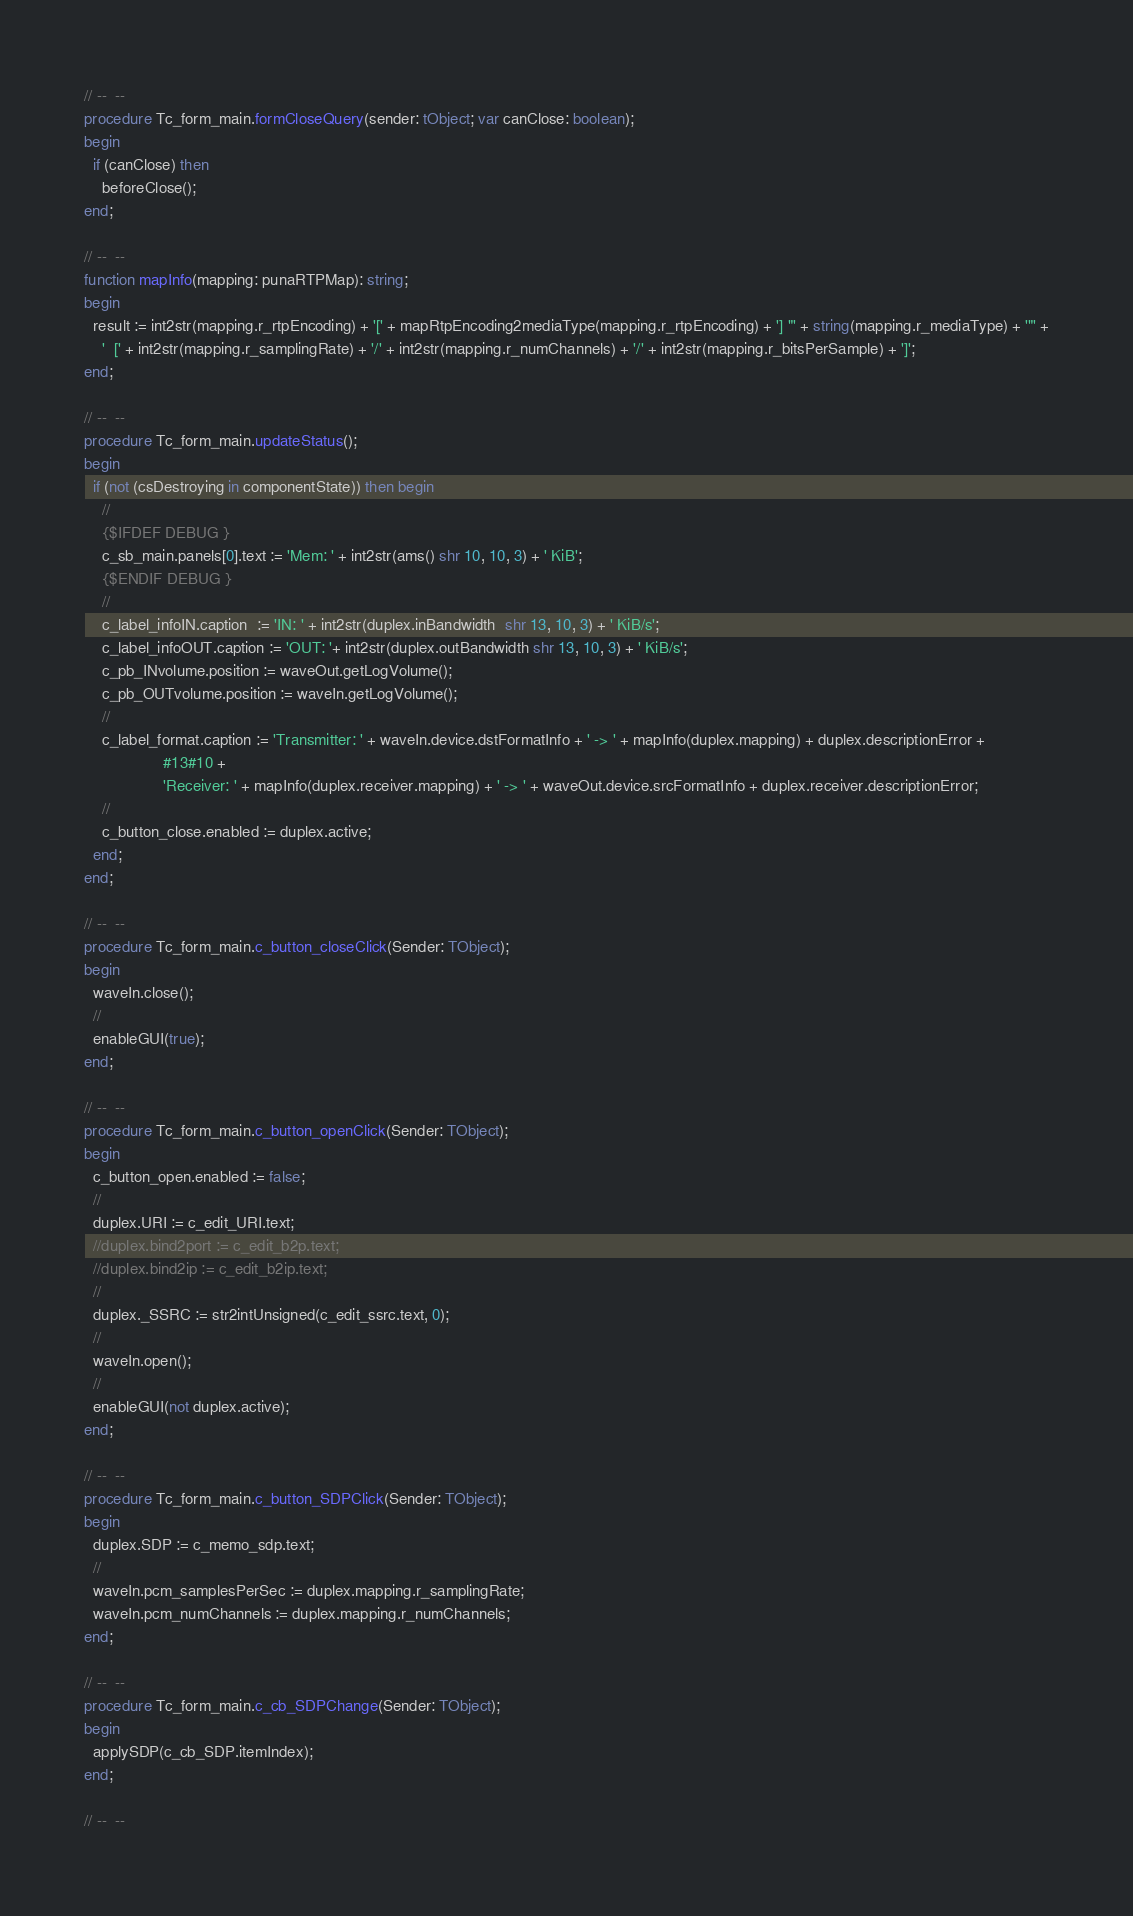Convert code to text. <code><loc_0><loc_0><loc_500><loc_500><_Pascal_>
// --  --
procedure Tc_form_main.formCloseQuery(sender: tObject; var canClose: boolean);
begin
  if (canClose) then
    beforeClose();
end;

// --  --
function mapInfo(mapping: punaRTPMap): string;
begin
  result := int2str(mapping.r_rtpEncoding) + '[' + mapRtpEncoding2mediaType(mapping.r_rtpEncoding) + '] "' + string(mapping.r_mediaType) + '"' +
    '  [' + int2str(mapping.r_samplingRate) + '/' + int2str(mapping.r_numChannels) + '/' + int2str(mapping.r_bitsPerSample) + ']';
end;

// --  --
procedure Tc_form_main.updateStatus();
begin
  if (not (csDestroying in componentState)) then begin
    //
    {$IFDEF DEBUG }
    c_sb_main.panels[0].text := 'Mem: ' + int2str(ams() shr 10, 10, 3) + ' KiB';
    {$ENDIF DEBUG }
    //
    c_label_infoIN.caption  := 'IN: ' + int2str(duplex.inBandwidth  shr 13, 10, 3) + ' KiB/s';
    c_label_infoOUT.caption := 'OUT: '+ int2str(duplex.outBandwidth shr 13, 10, 3) + ' KiB/s';
    c_pb_INvolume.position := waveOut.getLogVolume();
    c_pb_OUTvolume.position := waveIn.getLogVolume();
    //
    c_label_format.caption := 'Transmitter: ' + waveIn.device.dstFormatInfo + ' -> ' + mapInfo(duplex.mapping) + duplex.descriptionError +
			      #13#10 +
			      'Receiver: ' + mapInfo(duplex.receiver.mapping) + ' -> ' + waveOut.device.srcFormatInfo + duplex.receiver.descriptionError;
    //
    c_button_close.enabled := duplex.active;
  end;
end;

// --  --
procedure Tc_form_main.c_button_closeClick(Sender: TObject);
begin
  waveIn.close();
  //
  enableGUI(true);
end;

// --  --
procedure Tc_form_main.c_button_openClick(Sender: TObject);
begin
  c_button_open.enabled := false;
  //
  duplex.URI := c_edit_URI.text;
  //duplex.bind2port := c_edit_b2p.text;
  //duplex.bind2ip := c_edit_b2ip.text;
  //
  duplex._SSRC := str2intUnsigned(c_edit_ssrc.text, 0);
  //
  waveIn.open();
  //
  enableGUI(not duplex.active);
end;

// --  --
procedure Tc_form_main.c_button_SDPClick(Sender: TObject);
begin
  duplex.SDP := c_memo_sdp.text;
  //
  waveIn.pcm_samplesPerSec := duplex.mapping.r_samplingRate;
  waveIn.pcm_numChannels := duplex.mapping.r_numChannels;
end;

// --  --
procedure Tc_form_main.c_cb_SDPChange(Sender: TObject);
begin
  applySDP(c_cb_SDP.itemIndex);
end;

// --  --</code> 